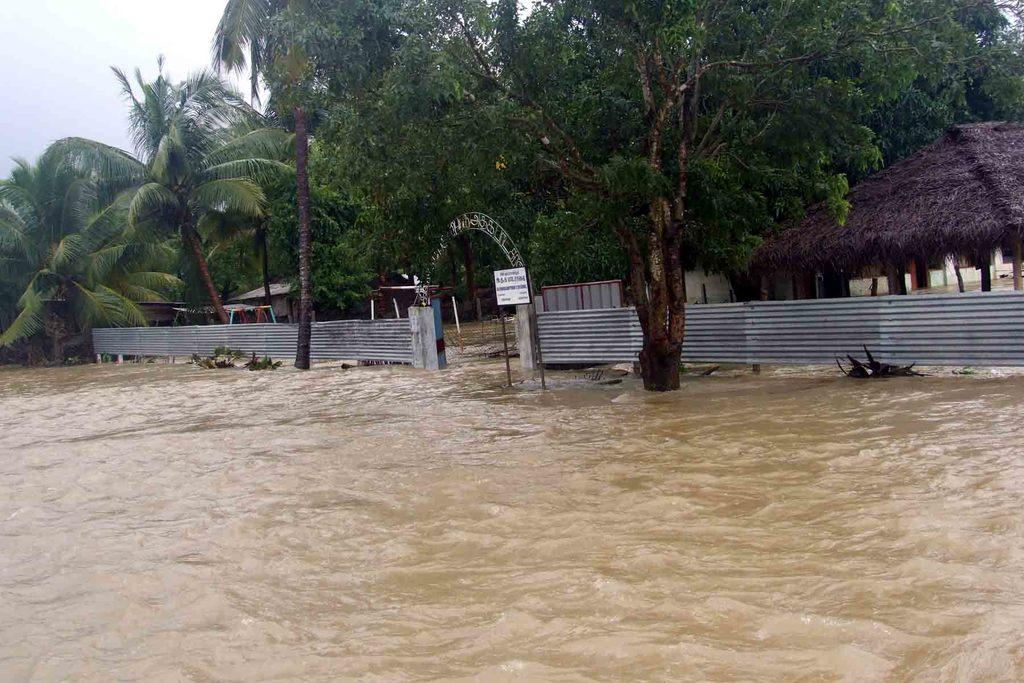What is in the foreground of the image? There is water in the foreground of the image. What can be seen in the background of the image? In the background of the image, there is a poster, metal sheets, huts, trees, and the sky. Can you describe the poster in the background? Unfortunately, the facts provided do not give any details about the poster. What type of structures are visible in the background? The structures in the background appear to be huts. What natural elements are present in the background? Trees and the sky are present in the background of the image. Can you tell me how many kittens are playing with a kite in the image? There are no kittens or kites present in the image. What is the level of hope depicted in the image? The facts provided do not give any information about the level of hope in the image. 